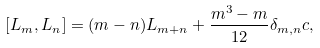Convert formula to latex. <formula><loc_0><loc_0><loc_500><loc_500>[ L _ { m } , L _ { n } ] = ( m - n ) L _ { m + n } + \frac { m ^ { 3 } - m } { 1 2 } \delta _ { m , n } c ,</formula> 